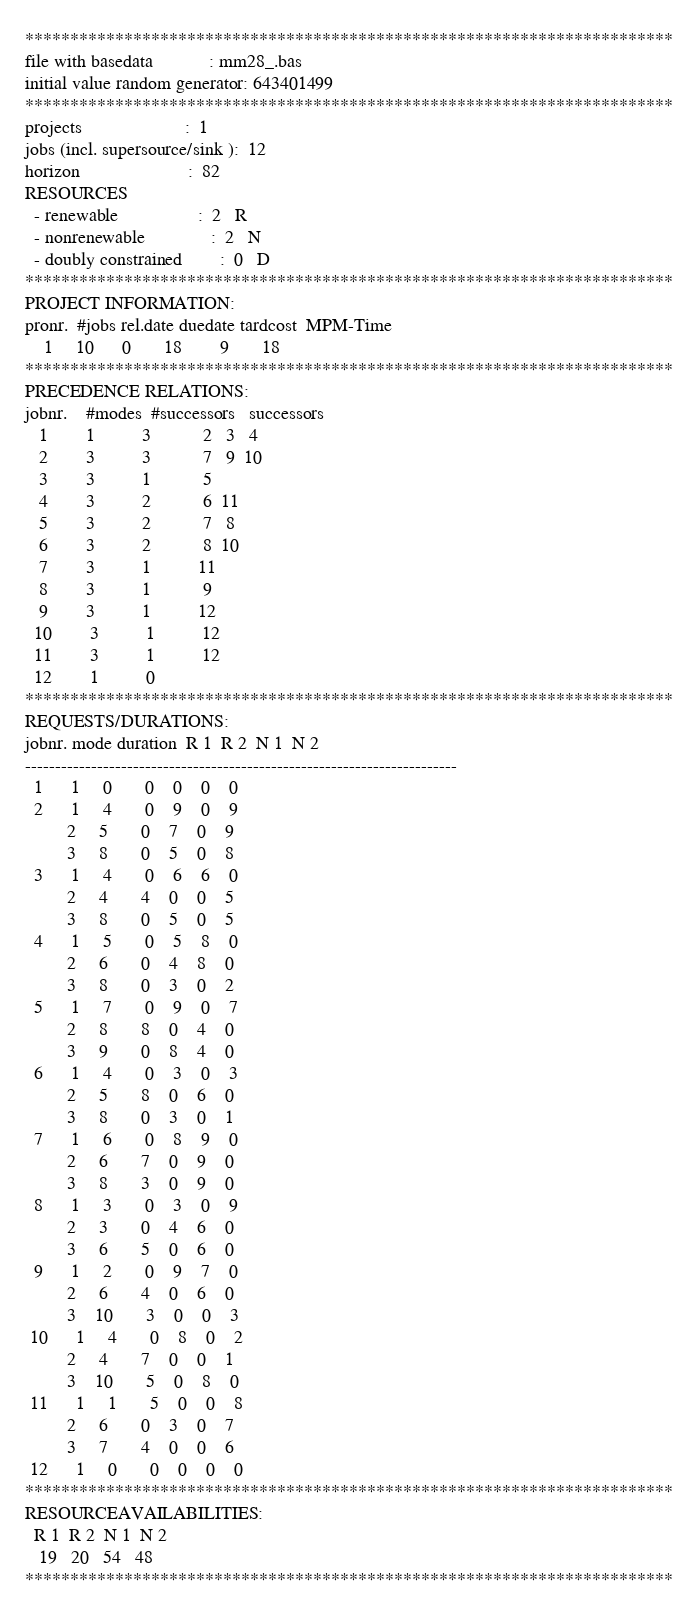Convert code to text. <code><loc_0><loc_0><loc_500><loc_500><_ObjectiveC_>************************************************************************
file with basedata            : mm28_.bas
initial value random generator: 643401499
************************************************************************
projects                      :  1
jobs (incl. supersource/sink ):  12
horizon                       :  82
RESOURCES
  - renewable                 :  2   R
  - nonrenewable              :  2   N
  - doubly constrained        :  0   D
************************************************************************
PROJECT INFORMATION:
pronr.  #jobs rel.date duedate tardcost  MPM-Time
    1     10      0       18        9       18
************************************************************************
PRECEDENCE RELATIONS:
jobnr.    #modes  #successors   successors
   1        1          3           2   3   4
   2        3          3           7   9  10
   3        3          1           5
   4        3          2           6  11
   5        3          2           7   8
   6        3          2           8  10
   7        3          1          11
   8        3          1           9
   9        3          1          12
  10        3          1          12
  11        3          1          12
  12        1          0        
************************************************************************
REQUESTS/DURATIONS:
jobnr. mode duration  R 1  R 2  N 1  N 2
------------------------------------------------------------------------
  1      1     0       0    0    0    0
  2      1     4       0    9    0    9
         2     5       0    7    0    9
         3     8       0    5    0    8
  3      1     4       0    6    6    0
         2     4       4    0    0    5
         3     8       0    5    0    5
  4      1     5       0    5    8    0
         2     6       0    4    8    0
         3     8       0    3    0    2
  5      1     7       0    9    0    7
         2     8       8    0    4    0
         3     9       0    8    4    0
  6      1     4       0    3    0    3
         2     5       8    0    6    0
         3     8       0    3    0    1
  7      1     6       0    8    9    0
         2     6       7    0    9    0
         3     8       3    0    9    0
  8      1     3       0    3    0    9
         2     3       0    4    6    0
         3     6       5    0    6    0
  9      1     2       0    9    7    0
         2     6       4    0    6    0
         3    10       3    0    0    3
 10      1     4       0    8    0    2
         2     4       7    0    0    1
         3    10       5    0    8    0
 11      1     1       5    0    0    8
         2     6       0    3    0    7
         3     7       4    0    0    6
 12      1     0       0    0    0    0
************************************************************************
RESOURCEAVAILABILITIES:
  R 1  R 2  N 1  N 2
   19   20   54   48
************************************************************************
</code> 